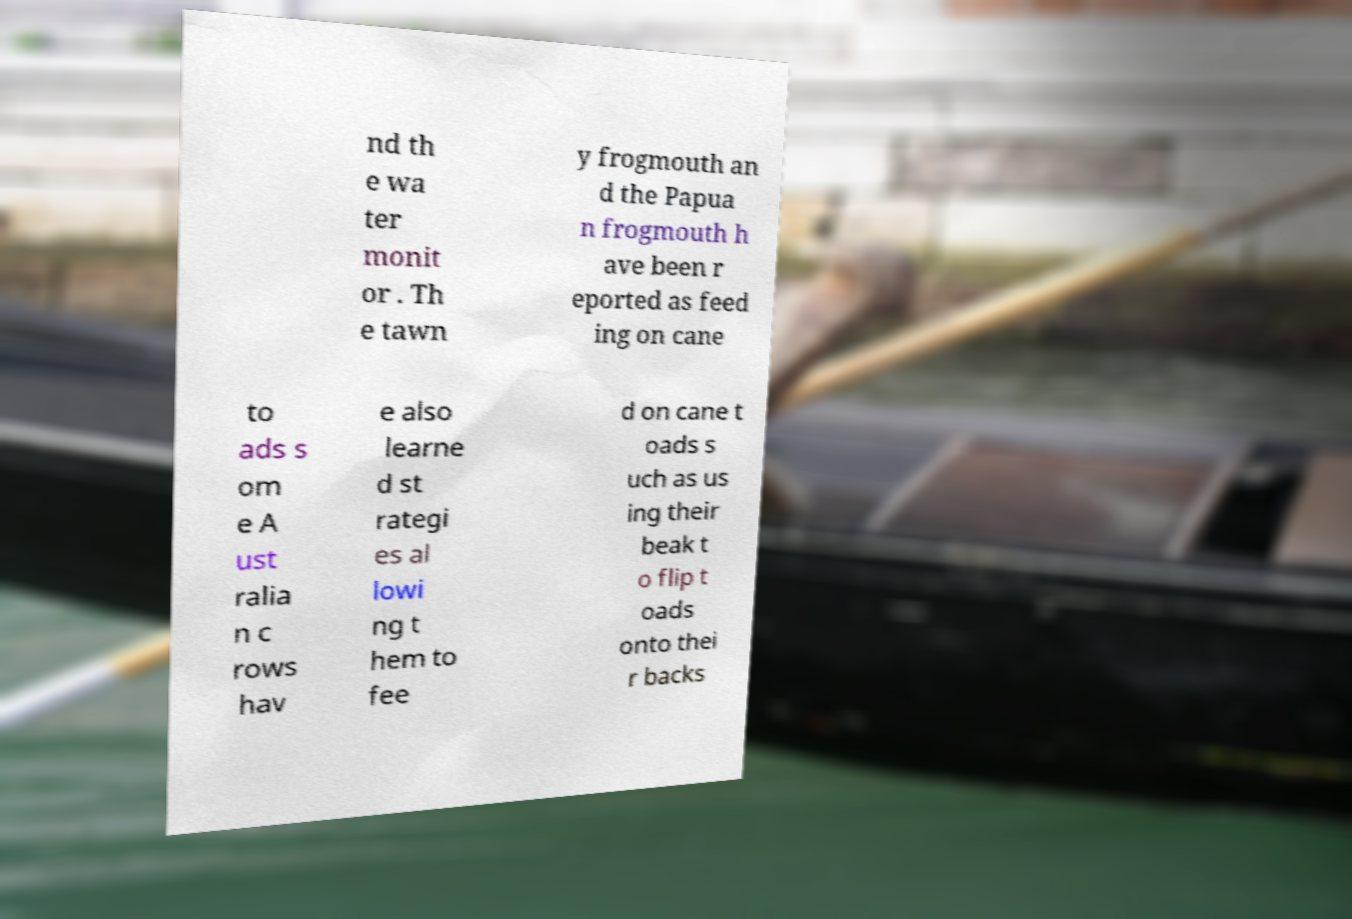Please read and relay the text visible in this image. What does it say? nd th e wa ter monit or . Th e tawn y frogmouth an d the Papua n frogmouth h ave been r eported as feed ing on cane to ads s om e A ust ralia n c rows hav e also learne d st rategi es al lowi ng t hem to fee d on cane t oads s uch as us ing their beak t o flip t oads onto thei r backs 